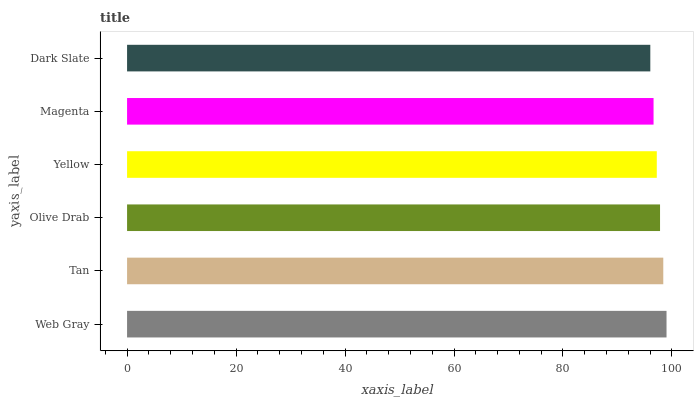Is Dark Slate the minimum?
Answer yes or no. Yes. Is Web Gray the maximum?
Answer yes or no. Yes. Is Tan the minimum?
Answer yes or no. No. Is Tan the maximum?
Answer yes or no. No. Is Web Gray greater than Tan?
Answer yes or no. Yes. Is Tan less than Web Gray?
Answer yes or no. Yes. Is Tan greater than Web Gray?
Answer yes or no. No. Is Web Gray less than Tan?
Answer yes or no. No. Is Olive Drab the high median?
Answer yes or no. Yes. Is Yellow the low median?
Answer yes or no. Yes. Is Dark Slate the high median?
Answer yes or no. No. Is Tan the low median?
Answer yes or no. No. 